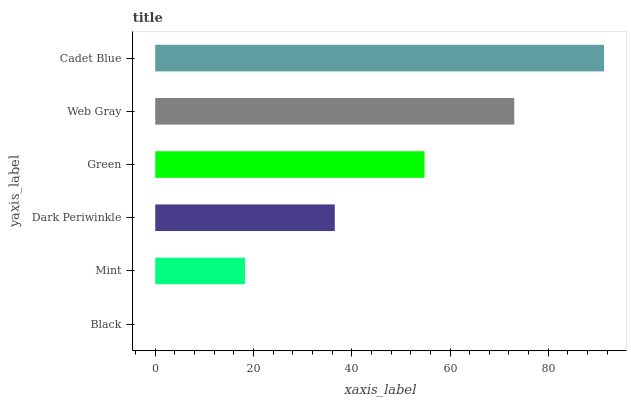Is Black the minimum?
Answer yes or no. Yes. Is Cadet Blue the maximum?
Answer yes or no. Yes. Is Mint the minimum?
Answer yes or no. No. Is Mint the maximum?
Answer yes or no. No. Is Mint greater than Black?
Answer yes or no. Yes. Is Black less than Mint?
Answer yes or no. Yes. Is Black greater than Mint?
Answer yes or no. No. Is Mint less than Black?
Answer yes or no. No. Is Green the high median?
Answer yes or no. Yes. Is Dark Periwinkle the low median?
Answer yes or no. Yes. Is Dark Periwinkle the high median?
Answer yes or no. No. Is Cadet Blue the low median?
Answer yes or no. No. 